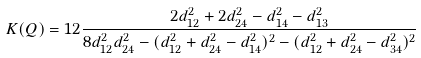<formula> <loc_0><loc_0><loc_500><loc_500>K ( Q ) = 1 2 \frac { 2 d _ { 1 2 } ^ { 2 } + 2 d _ { 2 4 } ^ { 2 } - d _ { 1 4 } ^ { 2 } - d _ { 1 3 } ^ { 2 } } { 8 d _ { 1 2 } ^ { 2 } d _ { 2 4 } ^ { 2 } - ( d _ { 1 2 } ^ { 2 } + d _ { 2 4 } ^ { 2 } - d _ { 1 4 } ^ { 2 } ) ^ { 2 } - ( d _ { 1 2 } ^ { 2 } + d _ { 2 4 } ^ { 2 } - d _ { 3 4 } ^ { 2 } ) ^ { 2 } }</formula> 